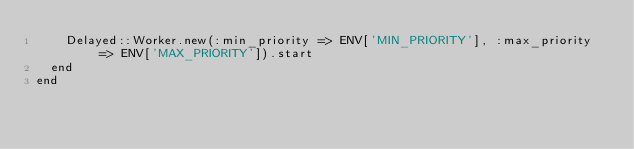<code> <loc_0><loc_0><loc_500><loc_500><_Ruby_>    Delayed::Worker.new(:min_priority => ENV['MIN_PRIORITY'], :max_priority => ENV['MAX_PRIORITY']).start
  end
end
</code> 